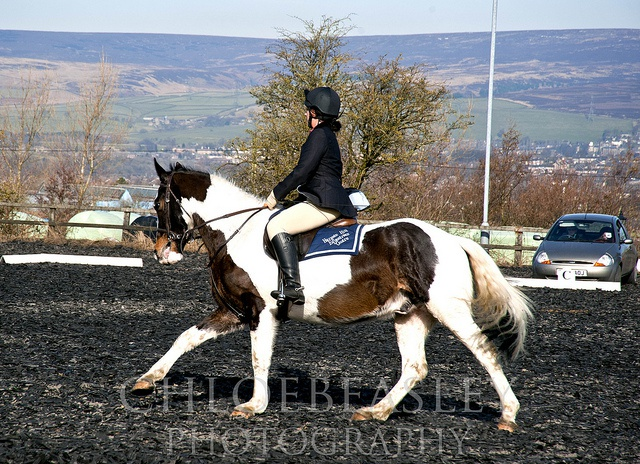Describe the objects in this image and their specific colors. I can see horse in lightblue, white, black, gray, and maroon tones, people in lightblue, black, beige, and gray tones, and car in lightblue, gray, black, blue, and white tones in this image. 